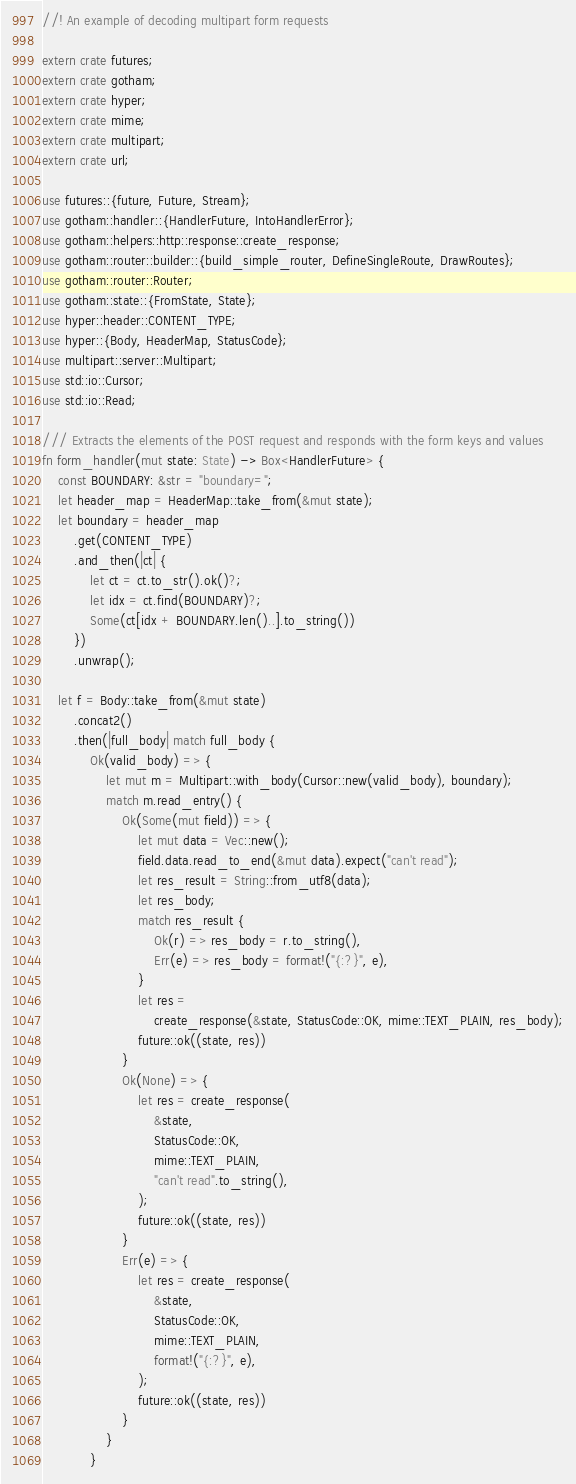Convert code to text. <code><loc_0><loc_0><loc_500><loc_500><_Rust_>//! An example of decoding multipart form requests

extern crate futures;
extern crate gotham;
extern crate hyper;
extern crate mime;
extern crate multipart;
extern crate url;

use futures::{future, Future, Stream};
use gotham::handler::{HandlerFuture, IntoHandlerError};
use gotham::helpers::http::response::create_response;
use gotham::router::builder::{build_simple_router, DefineSingleRoute, DrawRoutes};
use gotham::router::Router;
use gotham::state::{FromState, State};
use hyper::header::CONTENT_TYPE;
use hyper::{Body, HeaderMap, StatusCode};
use multipart::server::Multipart;
use std::io::Cursor;
use std::io::Read;

/// Extracts the elements of the POST request and responds with the form keys and values
fn form_handler(mut state: State) -> Box<HandlerFuture> {
    const BOUNDARY: &str = "boundary=";
    let header_map = HeaderMap::take_from(&mut state);
    let boundary = header_map
        .get(CONTENT_TYPE)
        .and_then(|ct| {
            let ct = ct.to_str().ok()?;
            let idx = ct.find(BOUNDARY)?;
            Some(ct[idx + BOUNDARY.len()..].to_string())
        })
        .unwrap();

    let f = Body::take_from(&mut state)
        .concat2()
        .then(|full_body| match full_body {
            Ok(valid_body) => {
                let mut m = Multipart::with_body(Cursor::new(valid_body), boundary);
                match m.read_entry() {
                    Ok(Some(mut field)) => {
                        let mut data = Vec::new();
                        field.data.read_to_end(&mut data).expect("can't read");
                        let res_result = String::from_utf8(data);
                        let res_body;
                        match res_result {
                            Ok(r) => res_body = r.to_string(),
                            Err(e) => res_body = format!("{:?}", e),
                        }
                        let res =
                            create_response(&state, StatusCode::OK, mime::TEXT_PLAIN, res_body);
                        future::ok((state, res))
                    }
                    Ok(None) => {
                        let res = create_response(
                            &state,
                            StatusCode::OK,
                            mime::TEXT_PLAIN,
                            "can't read".to_string(),
                        );
                        future::ok((state, res))
                    }
                    Err(e) => {
                        let res = create_response(
                            &state,
                            StatusCode::OK,
                            mime::TEXT_PLAIN,
                            format!("{:?}", e),
                        );
                        future::ok((state, res))
                    }
                }
            }</code> 